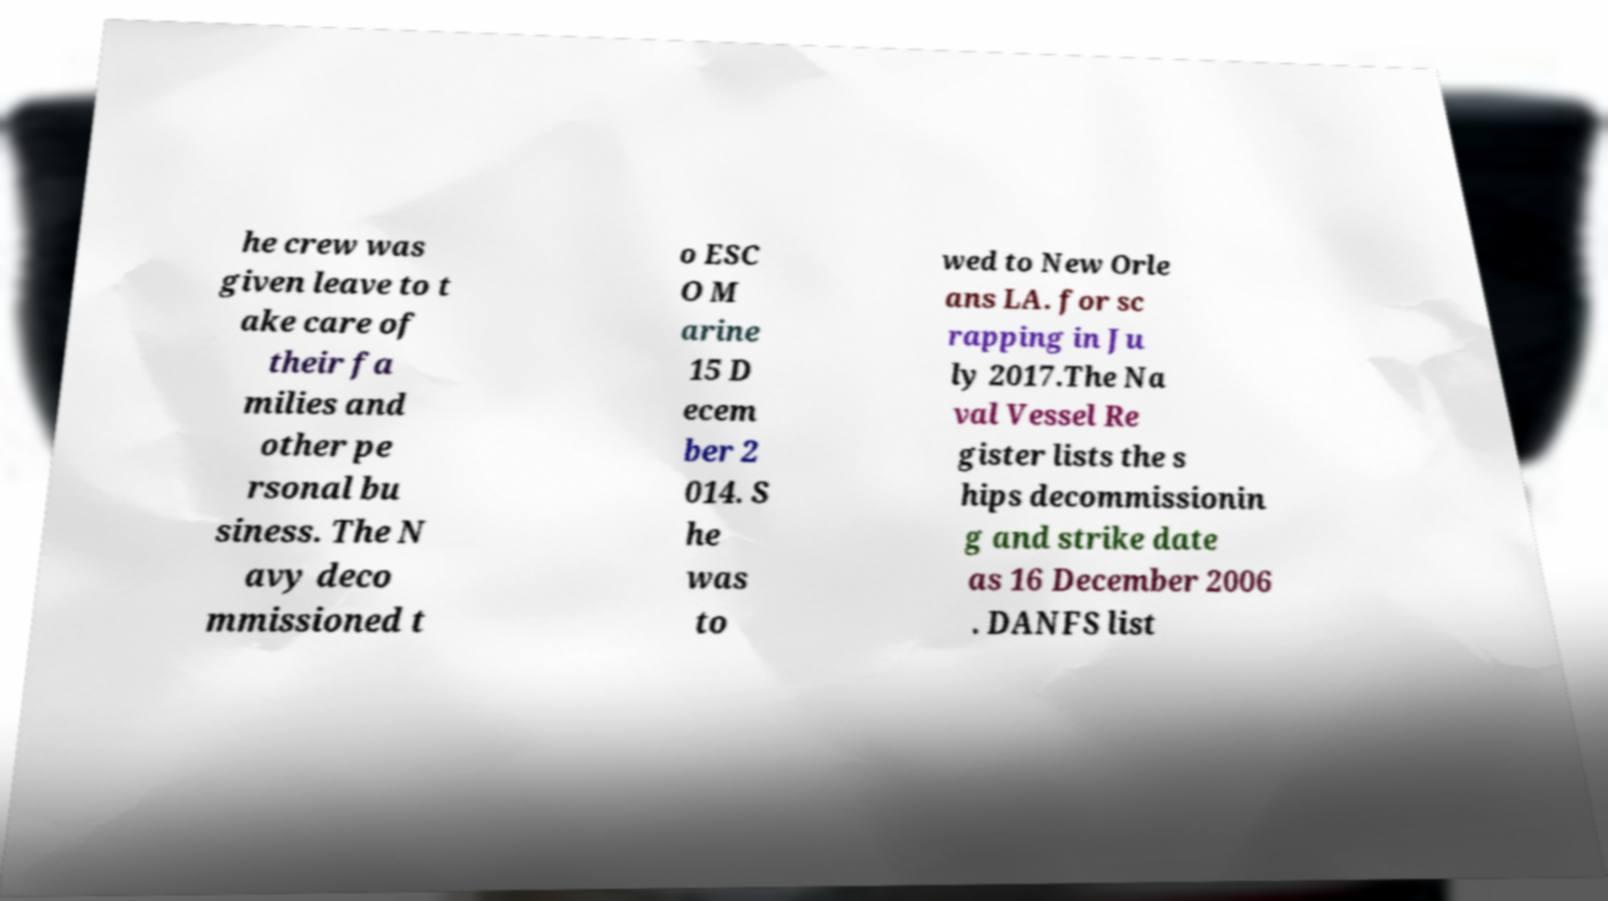Can you read and provide the text displayed in the image?This photo seems to have some interesting text. Can you extract and type it out for me? he crew was given leave to t ake care of their fa milies and other pe rsonal bu siness. The N avy deco mmissioned t o ESC O M arine 15 D ecem ber 2 014. S he was to wed to New Orle ans LA. for sc rapping in Ju ly 2017.The Na val Vessel Re gister lists the s hips decommissionin g and strike date as 16 December 2006 . DANFS list 